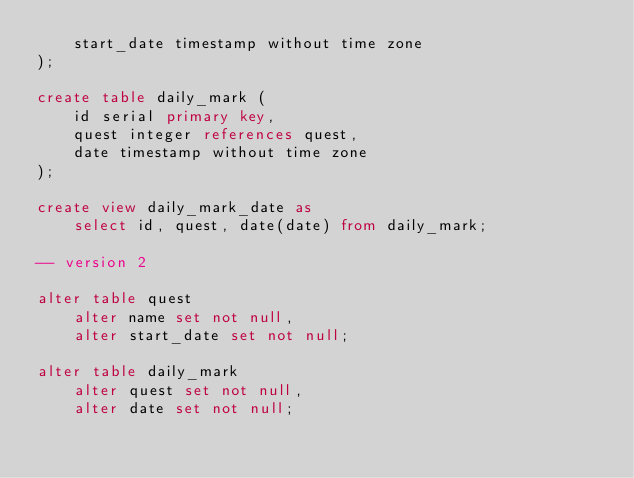<code> <loc_0><loc_0><loc_500><loc_500><_SQL_>    start_date timestamp without time zone
);

create table daily_mark (
    id serial primary key,
    quest integer references quest,
    date timestamp without time zone
);

create view daily_mark_date as
    select id, quest, date(date) from daily_mark;

-- version 2

alter table quest
    alter name set not null,
    alter start_date set not null;

alter table daily_mark
    alter quest set not null,
    alter date set not null;
</code> 